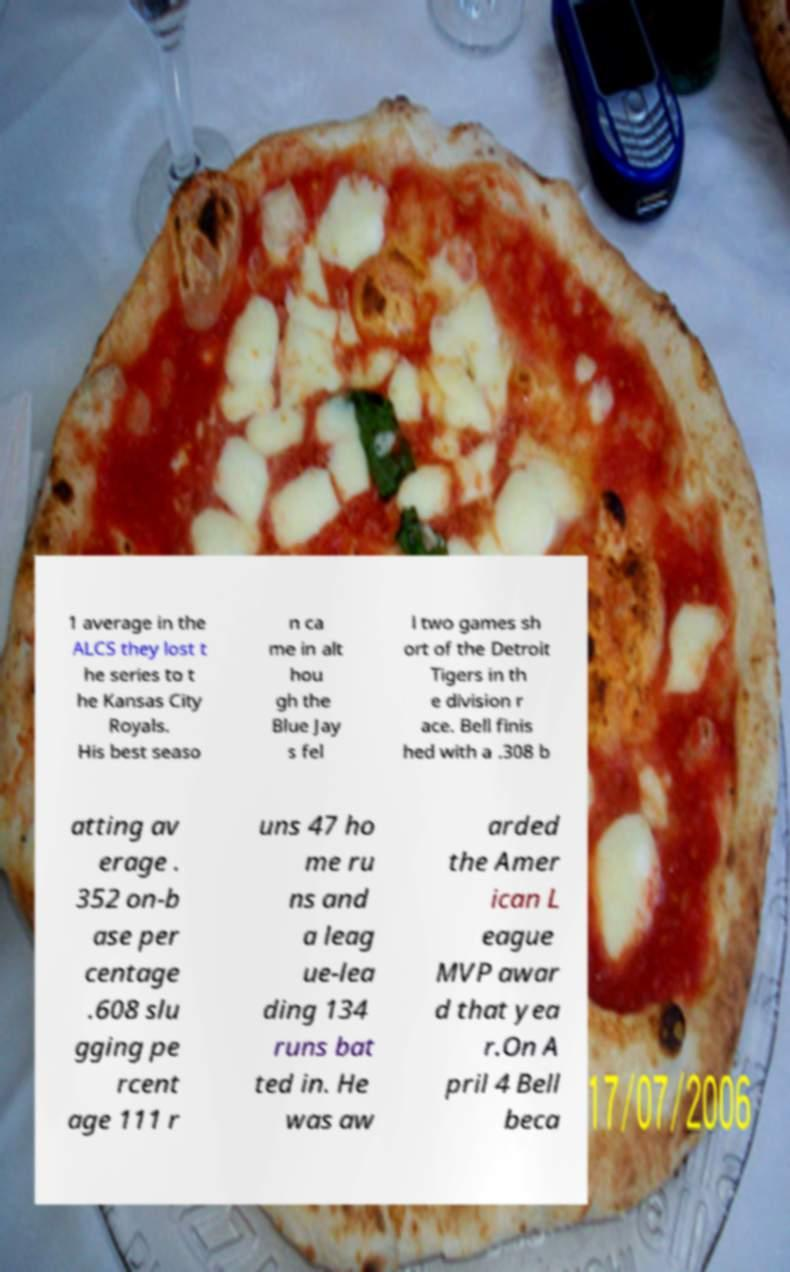Could you extract and type out the text from this image? 1 average in the ALCS they lost t he series to t he Kansas City Royals. His best seaso n ca me in alt hou gh the Blue Jay s fel l two games sh ort of the Detroit Tigers in th e division r ace. Bell finis hed with a .308 b atting av erage . 352 on-b ase per centage .608 slu gging pe rcent age 111 r uns 47 ho me ru ns and a leag ue-lea ding 134 runs bat ted in. He was aw arded the Amer ican L eague MVP awar d that yea r.On A pril 4 Bell beca 